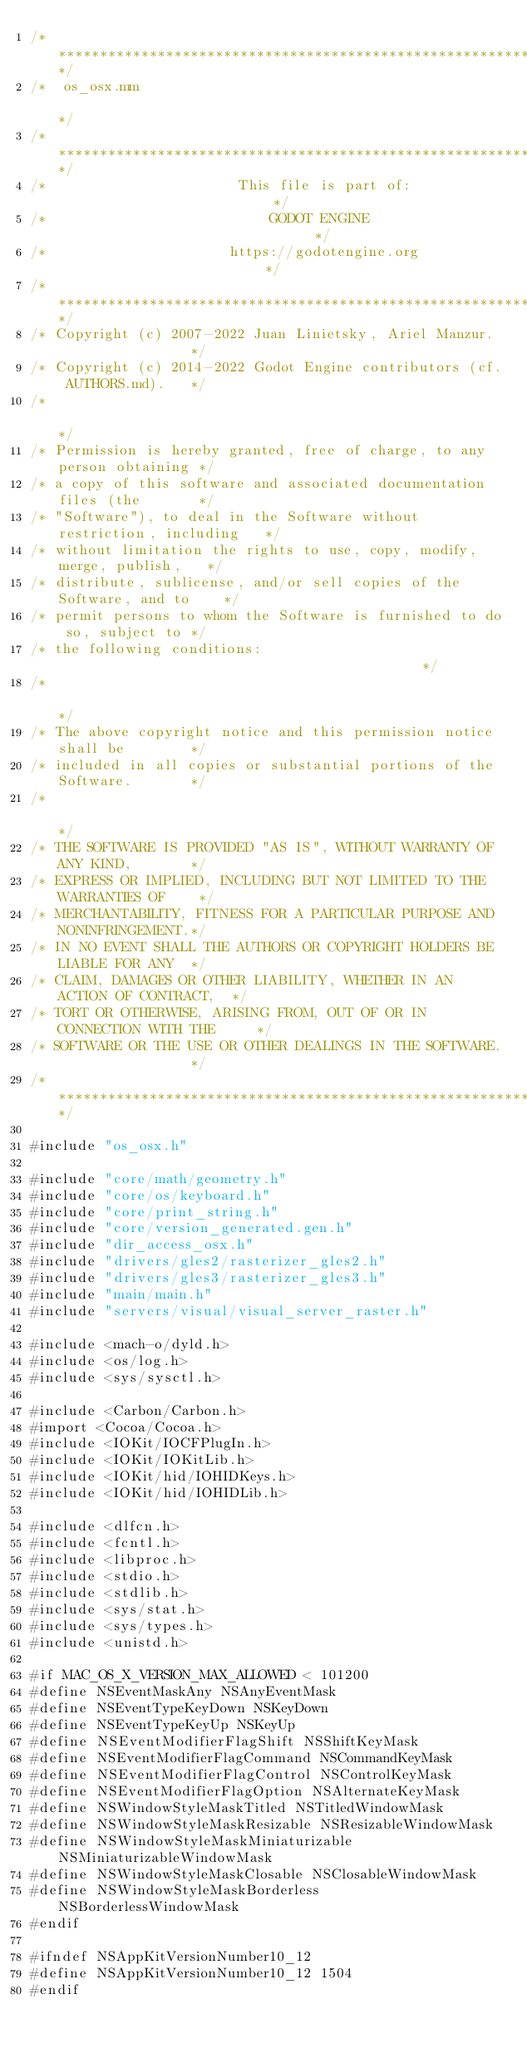<code> <loc_0><loc_0><loc_500><loc_500><_ObjectiveC_>/*************************************************************************/
/*  os_osx.mm                                                            */
/*************************************************************************/
/*                       This file is part of:                           */
/*                           GODOT ENGINE                                */
/*                      https://godotengine.org                          */
/*************************************************************************/
/* Copyright (c) 2007-2022 Juan Linietsky, Ariel Manzur.                 */
/* Copyright (c) 2014-2022 Godot Engine contributors (cf. AUTHORS.md).   */
/*                                                                       */
/* Permission is hereby granted, free of charge, to any person obtaining */
/* a copy of this software and associated documentation files (the       */
/* "Software"), to deal in the Software without restriction, including   */
/* without limitation the rights to use, copy, modify, merge, publish,   */
/* distribute, sublicense, and/or sell copies of the Software, and to    */
/* permit persons to whom the Software is furnished to do so, subject to */
/* the following conditions:                                             */
/*                                                                       */
/* The above copyright notice and this permission notice shall be        */
/* included in all copies or substantial portions of the Software.       */
/*                                                                       */
/* THE SOFTWARE IS PROVIDED "AS IS", WITHOUT WARRANTY OF ANY KIND,       */
/* EXPRESS OR IMPLIED, INCLUDING BUT NOT LIMITED TO THE WARRANTIES OF    */
/* MERCHANTABILITY, FITNESS FOR A PARTICULAR PURPOSE AND NONINFRINGEMENT.*/
/* IN NO EVENT SHALL THE AUTHORS OR COPYRIGHT HOLDERS BE LIABLE FOR ANY  */
/* CLAIM, DAMAGES OR OTHER LIABILITY, WHETHER IN AN ACTION OF CONTRACT,  */
/* TORT OR OTHERWISE, ARISING FROM, OUT OF OR IN CONNECTION WITH THE     */
/* SOFTWARE OR THE USE OR OTHER DEALINGS IN THE SOFTWARE.                */
/*************************************************************************/

#include "os_osx.h"

#include "core/math/geometry.h"
#include "core/os/keyboard.h"
#include "core/print_string.h"
#include "core/version_generated.gen.h"
#include "dir_access_osx.h"
#include "drivers/gles2/rasterizer_gles2.h"
#include "drivers/gles3/rasterizer_gles3.h"
#include "main/main.h"
#include "servers/visual/visual_server_raster.h"

#include <mach-o/dyld.h>
#include <os/log.h>
#include <sys/sysctl.h>

#include <Carbon/Carbon.h>
#import <Cocoa/Cocoa.h>
#include <IOKit/IOCFPlugIn.h>
#include <IOKit/IOKitLib.h>
#include <IOKit/hid/IOHIDKeys.h>
#include <IOKit/hid/IOHIDLib.h>

#include <dlfcn.h>
#include <fcntl.h>
#include <libproc.h>
#include <stdio.h>
#include <stdlib.h>
#include <sys/stat.h>
#include <sys/types.h>
#include <unistd.h>

#if MAC_OS_X_VERSION_MAX_ALLOWED < 101200
#define NSEventMaskAny NSAnyEventMask
#define NSEventTypeKeyDown NSKeyDown
#define NSEventTypeKeyUp NSKeyUp
#define NSEventModifierFlagShift NSShiftKeyMask
#define NSEventModifierFlagCommand NSCommandKeyMask
#define NSEventModifierFlagControl NSControlKeyMask
#define NSEventModifierFlagOption NSAlternateKeyMask
#define NSWindowStyleMaskTitled NSTitledWindowMask
#define NSWindowStyleMaskResizable NSResizableWindowMask
#define NSWindowStyleMaskMiniaturizable NSMiniaturizableWindowMask
#define NSWindowStyleMaskClosable NSClosableWindowMask
#define NSWindowStyleMaskBorderless NSBorderlessWindowMask
#endif

#ifndef NSAppKitVersionNumber10_12
#define NSAppKitVersionNumber10_12 1504
#endif</code> 